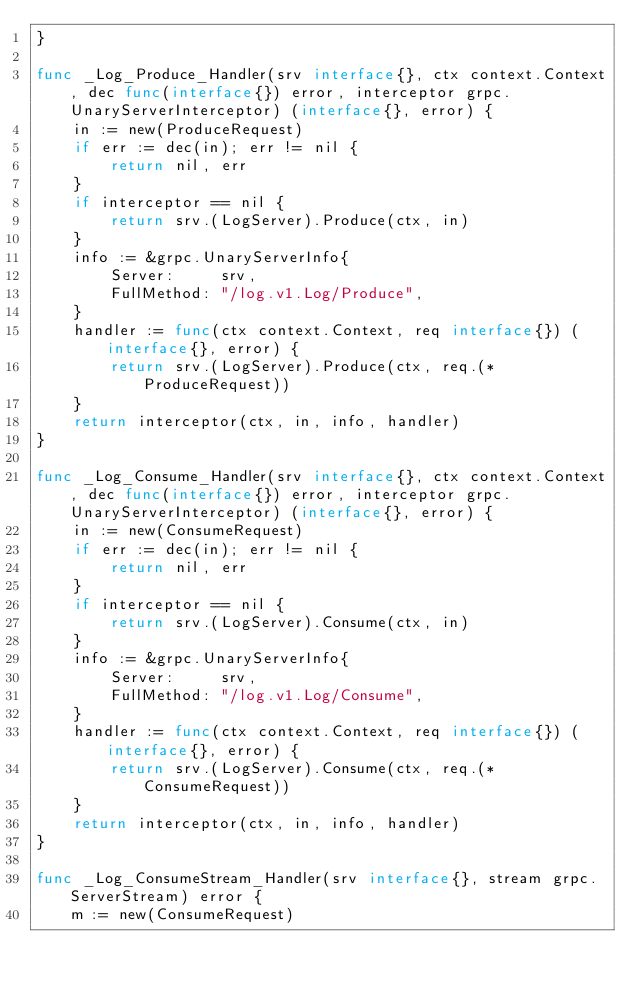Convert code to text. <code><loc_0><loc_0><loc_500><loc_500><_Go_>}

func _Log_Produce_Handler(srv interface{}, ctx context.Context, dec func(interface{}) error, interceptor grpc.UnaryServerInterceptor) (interface{}, error) {
	in := new(ProduceRequest)
	if err := dec(in); err != nil {
		return nil, err
	}
	if interceptor == nil {
		return srv.(LogServer).Produce(ctx, in)
	}
	info := &grpc.UnaryServerInfo{
		Server:     srv,
		FullMethod: "/log.v1.Log/Produce",
	}
	handler := func(ctx context.Context, req interface{}) (interface{}, error) {
		return srv.(LogServer).Produce(ctx, req.(*ProduceRequest))
	}
	return interceptor(ctx, in, info, handler)
}

func _Log_Consume_Handler(srv interface{}, ctx context.Context, dec func(interface{}) error, interceptor grpc.UnaryServerInterceptor) (interface{}, error) {
	in := new(ConsumeRequest)
	if err := dec(in); err != nil {
		return nil, err
	}
	if interceptor == nil {
		return srv.(LogServer).Consume(ctx, in)
	}
	info := &grpc.UnaryServerInfo{
		Server:     srv,
		FullMethod: "/log.v1.Log/Consume",
	}
	handler := func(ctx context.Context, req interface{}) (interface{}, error) {
		return srv.(LogServer).Consume(ctx, req.(*ConsumeRequest))
	}
	return interceptor(ctx, in, info, handler)
}

func _Log_ConsumeStream_Handler(srv interface{}, stream grpc.ServerStream) error {
	m := new(ConsumeRequest)</code> 